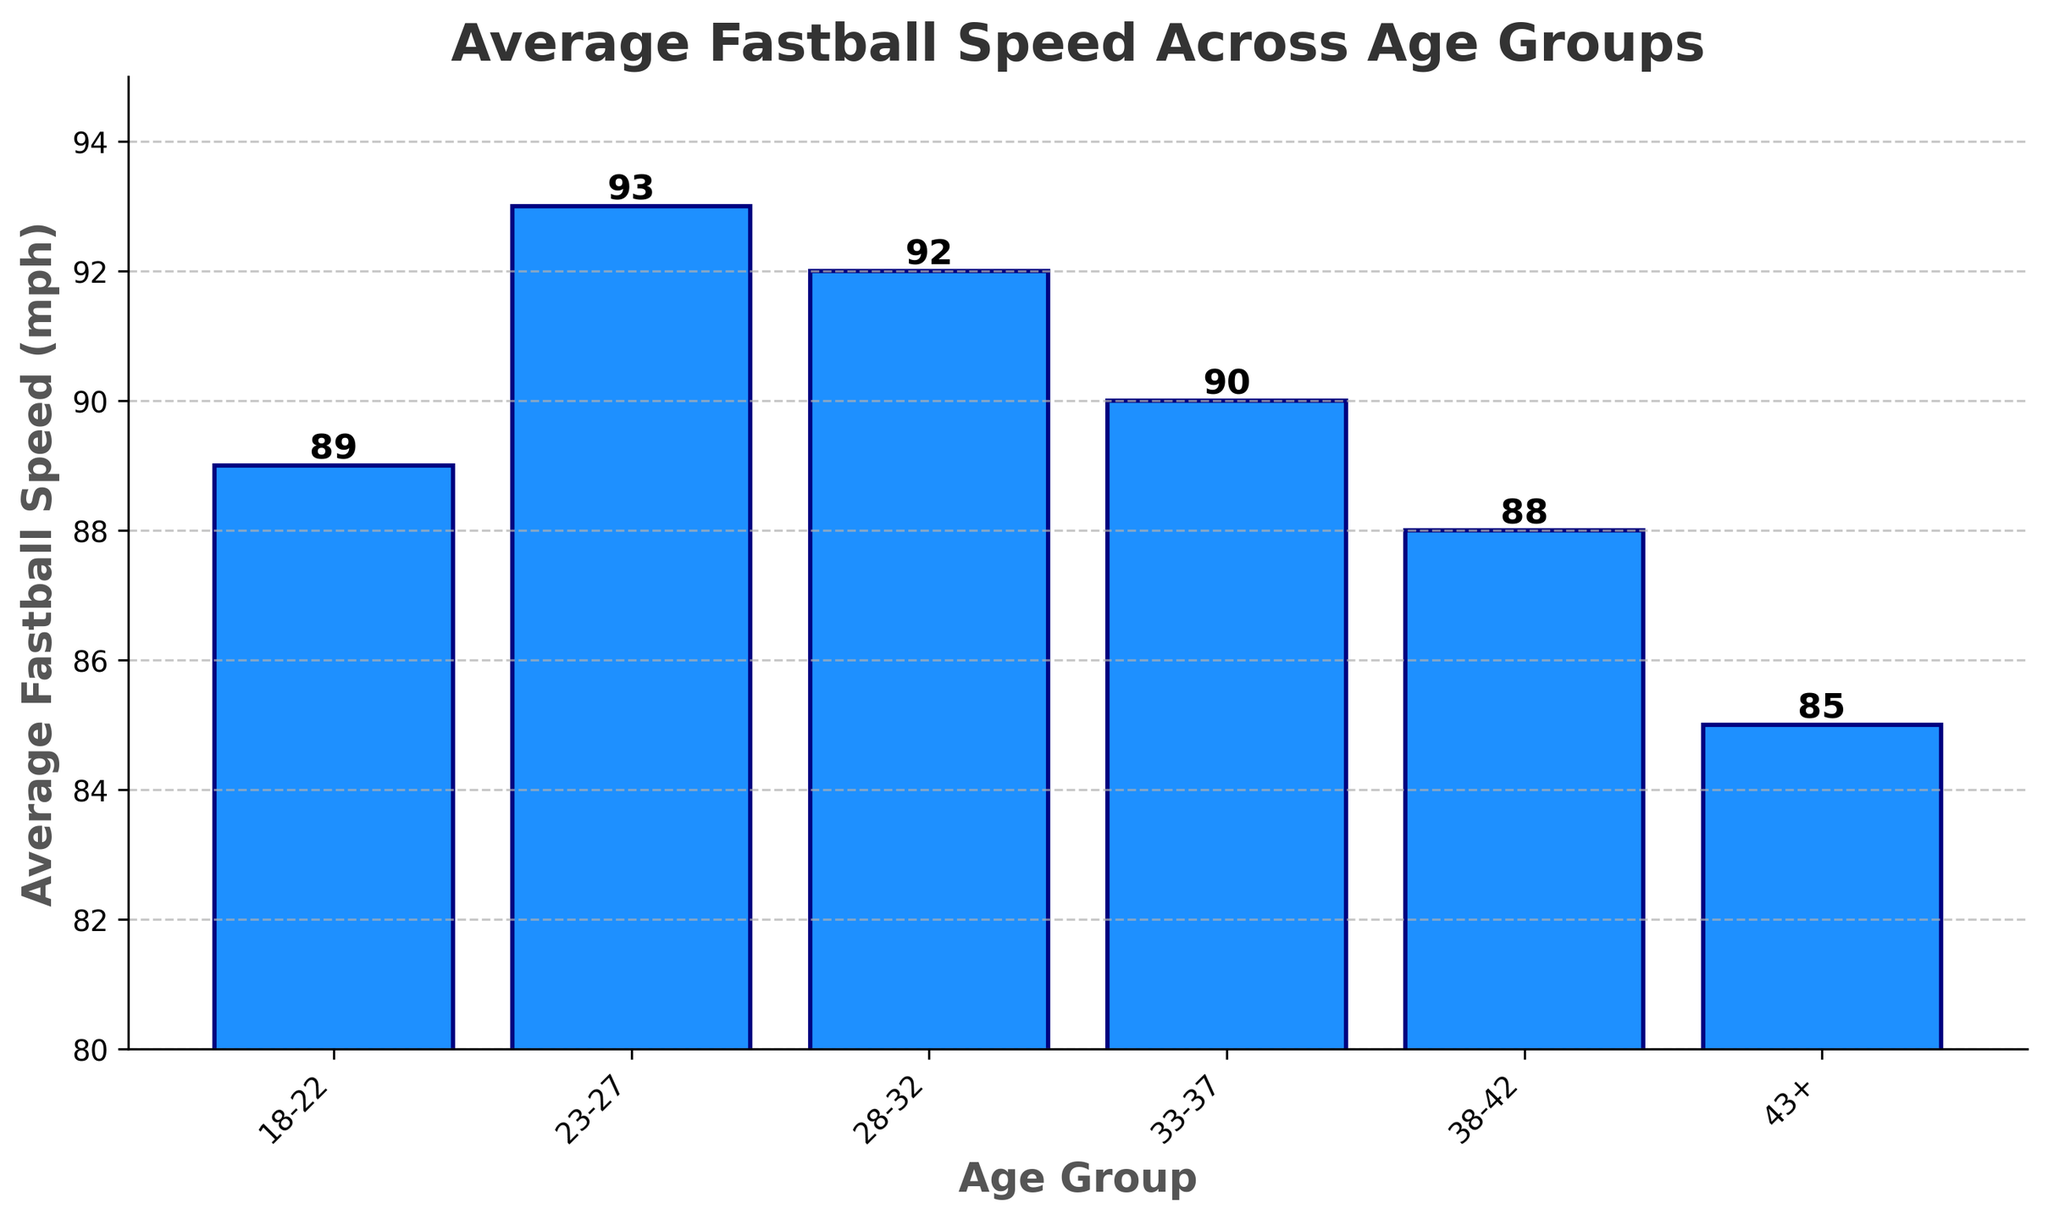What is the average fastball speed for the age group 28-32? Look at the bar height corresponding to the age group 28-32 on the x-axis.
Answer: 92 mph Which age group has the lowest average fastball speed? Identify the bar with the shortest height.
Answer: 43+ What is the difference in average fastball speed between the age groups 23-27 and 38-42? Subtract the average fastball speed of 38-42 (88 mph) from that of 23-27 (93 mph).
Answer: 5 mph Which age group has a higher average fastball speed, 33-37 or 18-22? Compare the height of the bars for these two age groups.
Answer: 33-37 What is the median average fastball speed across all age groups? Order the speeds: 85, 88, 89, 90, 92, 93. The median is the middle value(s), which is the average of the 3rd and 4th values. (89 + 90) / 2
Answer: 89.5 mph How many age groups have an average fastball speed above 90 mph? Count the number of bars with heights greater than 90 mph.
Answer: 2 What is the approximate range of average fastball speeds across all age groups? Subtract the smallest speed (85 mph) from the largest speed (93 mph).
Answer: 8 mph Which age groups have an average fastball speed exactly equal to 90 mph? Find the bar with the height indicating 90 mph and identify the corresponding age group.
Answer: 33-37 By how much does the average fastball speed of the 18-22 age group exceed that of the 43+ age group? Subtract the average fastball speed of 43+ (85 mph) from that of 18-22 (89 mph).
Answer: 4 mph What is the combined average fastball speed of the age groups 18-22, 28-32, and 33-37? Sum the average fastball speeds of these age groups: 89 + 92 + 90.
Answer: 271 mph 